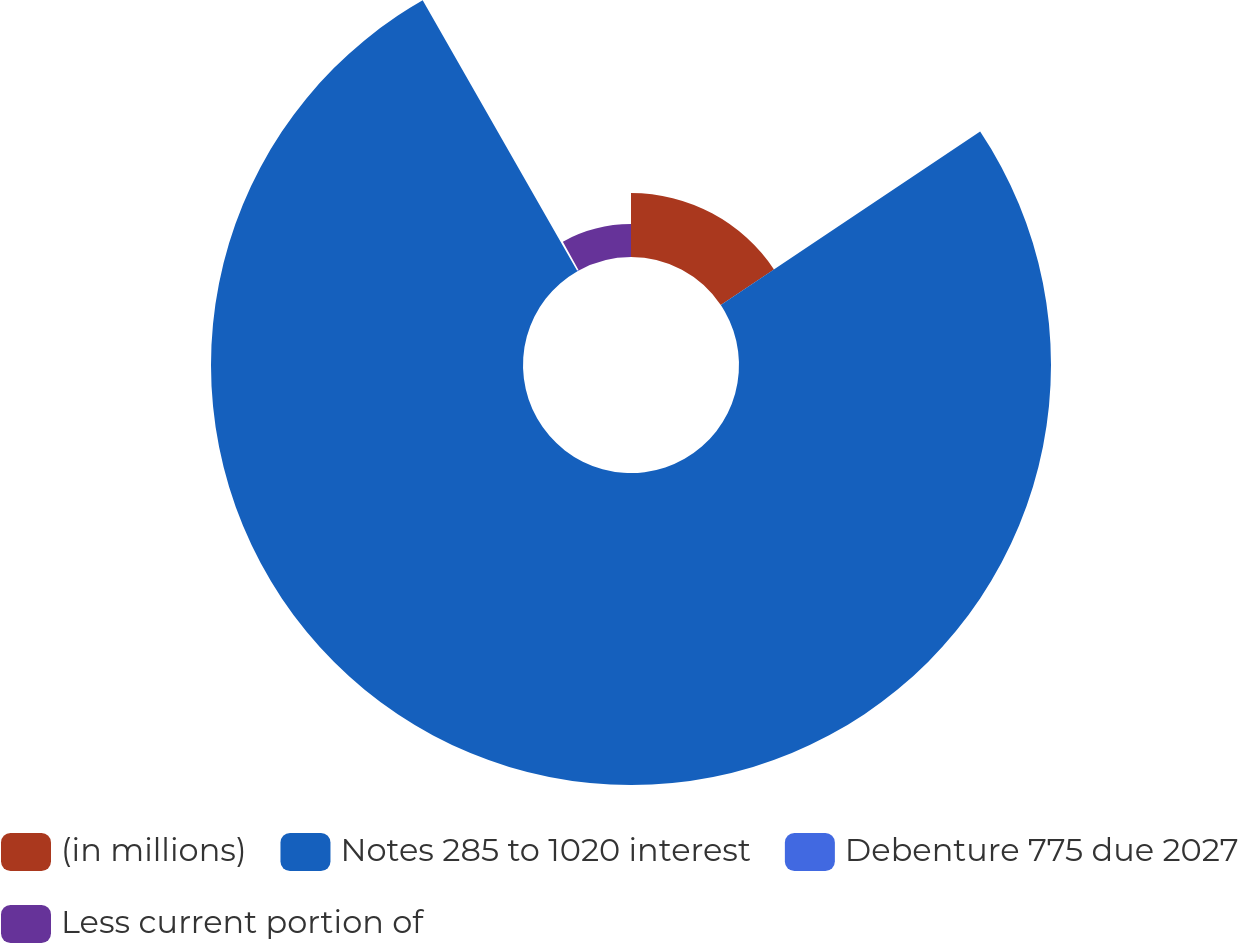<chart> <loc_0><loc_0><loc_500><loc_500><pie_chart><fcel>(in millions)<fcel>Notes 285 to 1020 interest<fcel>Debenture 775 due 2027<fcel>Less current portion of<nl><fcel>15.62%<fcel>76.12%<fcel>0.23%<fcel>8.03%<nl></chart> 